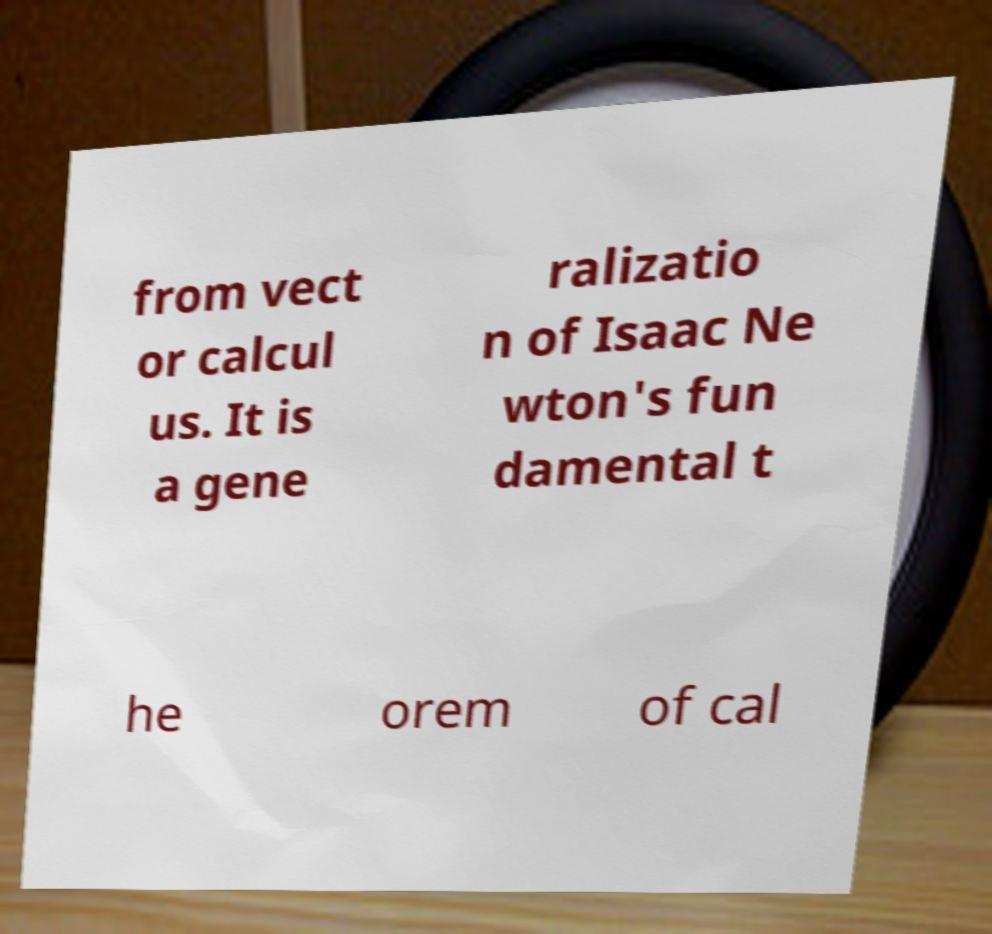Please read and relay the text visible in this image. What does it say? from vect or calcul us. It is a gene ralizatio n of Isaac Ne wton's fun damental t he orem of cal 